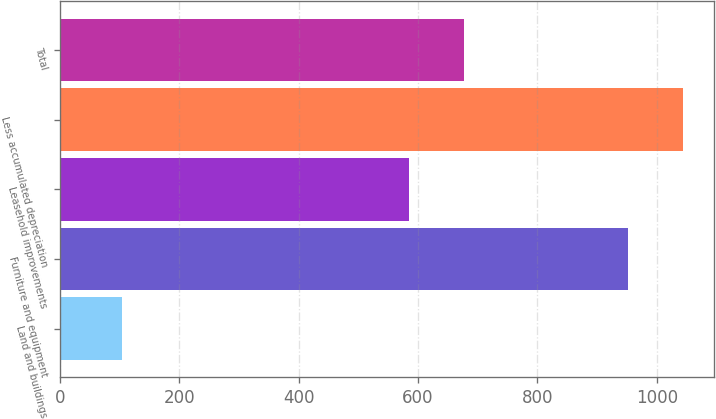Convert chart. <chart><loc_0><loc_0><loc_500><loc_500><bar_chart><fcel>Land and buildings<fcel>Furniture and equipment<fcel>Leasehold improvements<fcel>Less accumulated depreciation<fcel>Total<nl><fcel>104.1<fcel>952<fcel>584.9<fcel>1043.29<fcel>676.19<nl></chart> 